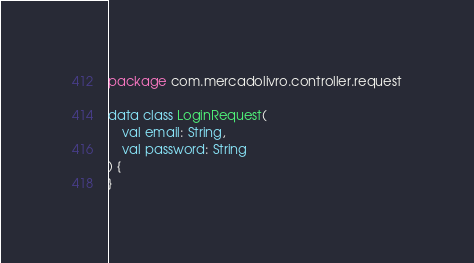<code> <loc_0><loc_0><loc_500><loc_500><_Kotlin_>package com.mercadolivro.controller.request

data class LoginRequest(
    val email: String,
    val password: String
) {
}</code> 